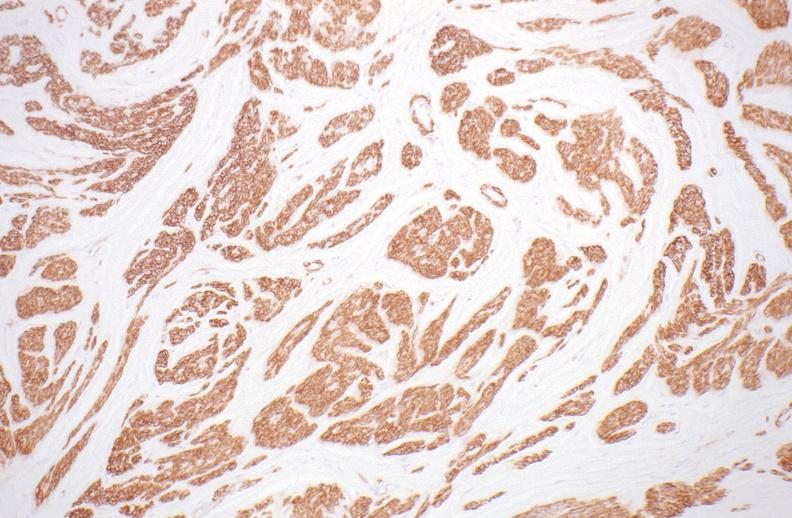what stain?
Answer the question using a single word or phrase. Leiomyoma, alpha smooth muscle actin immunohistochemical 